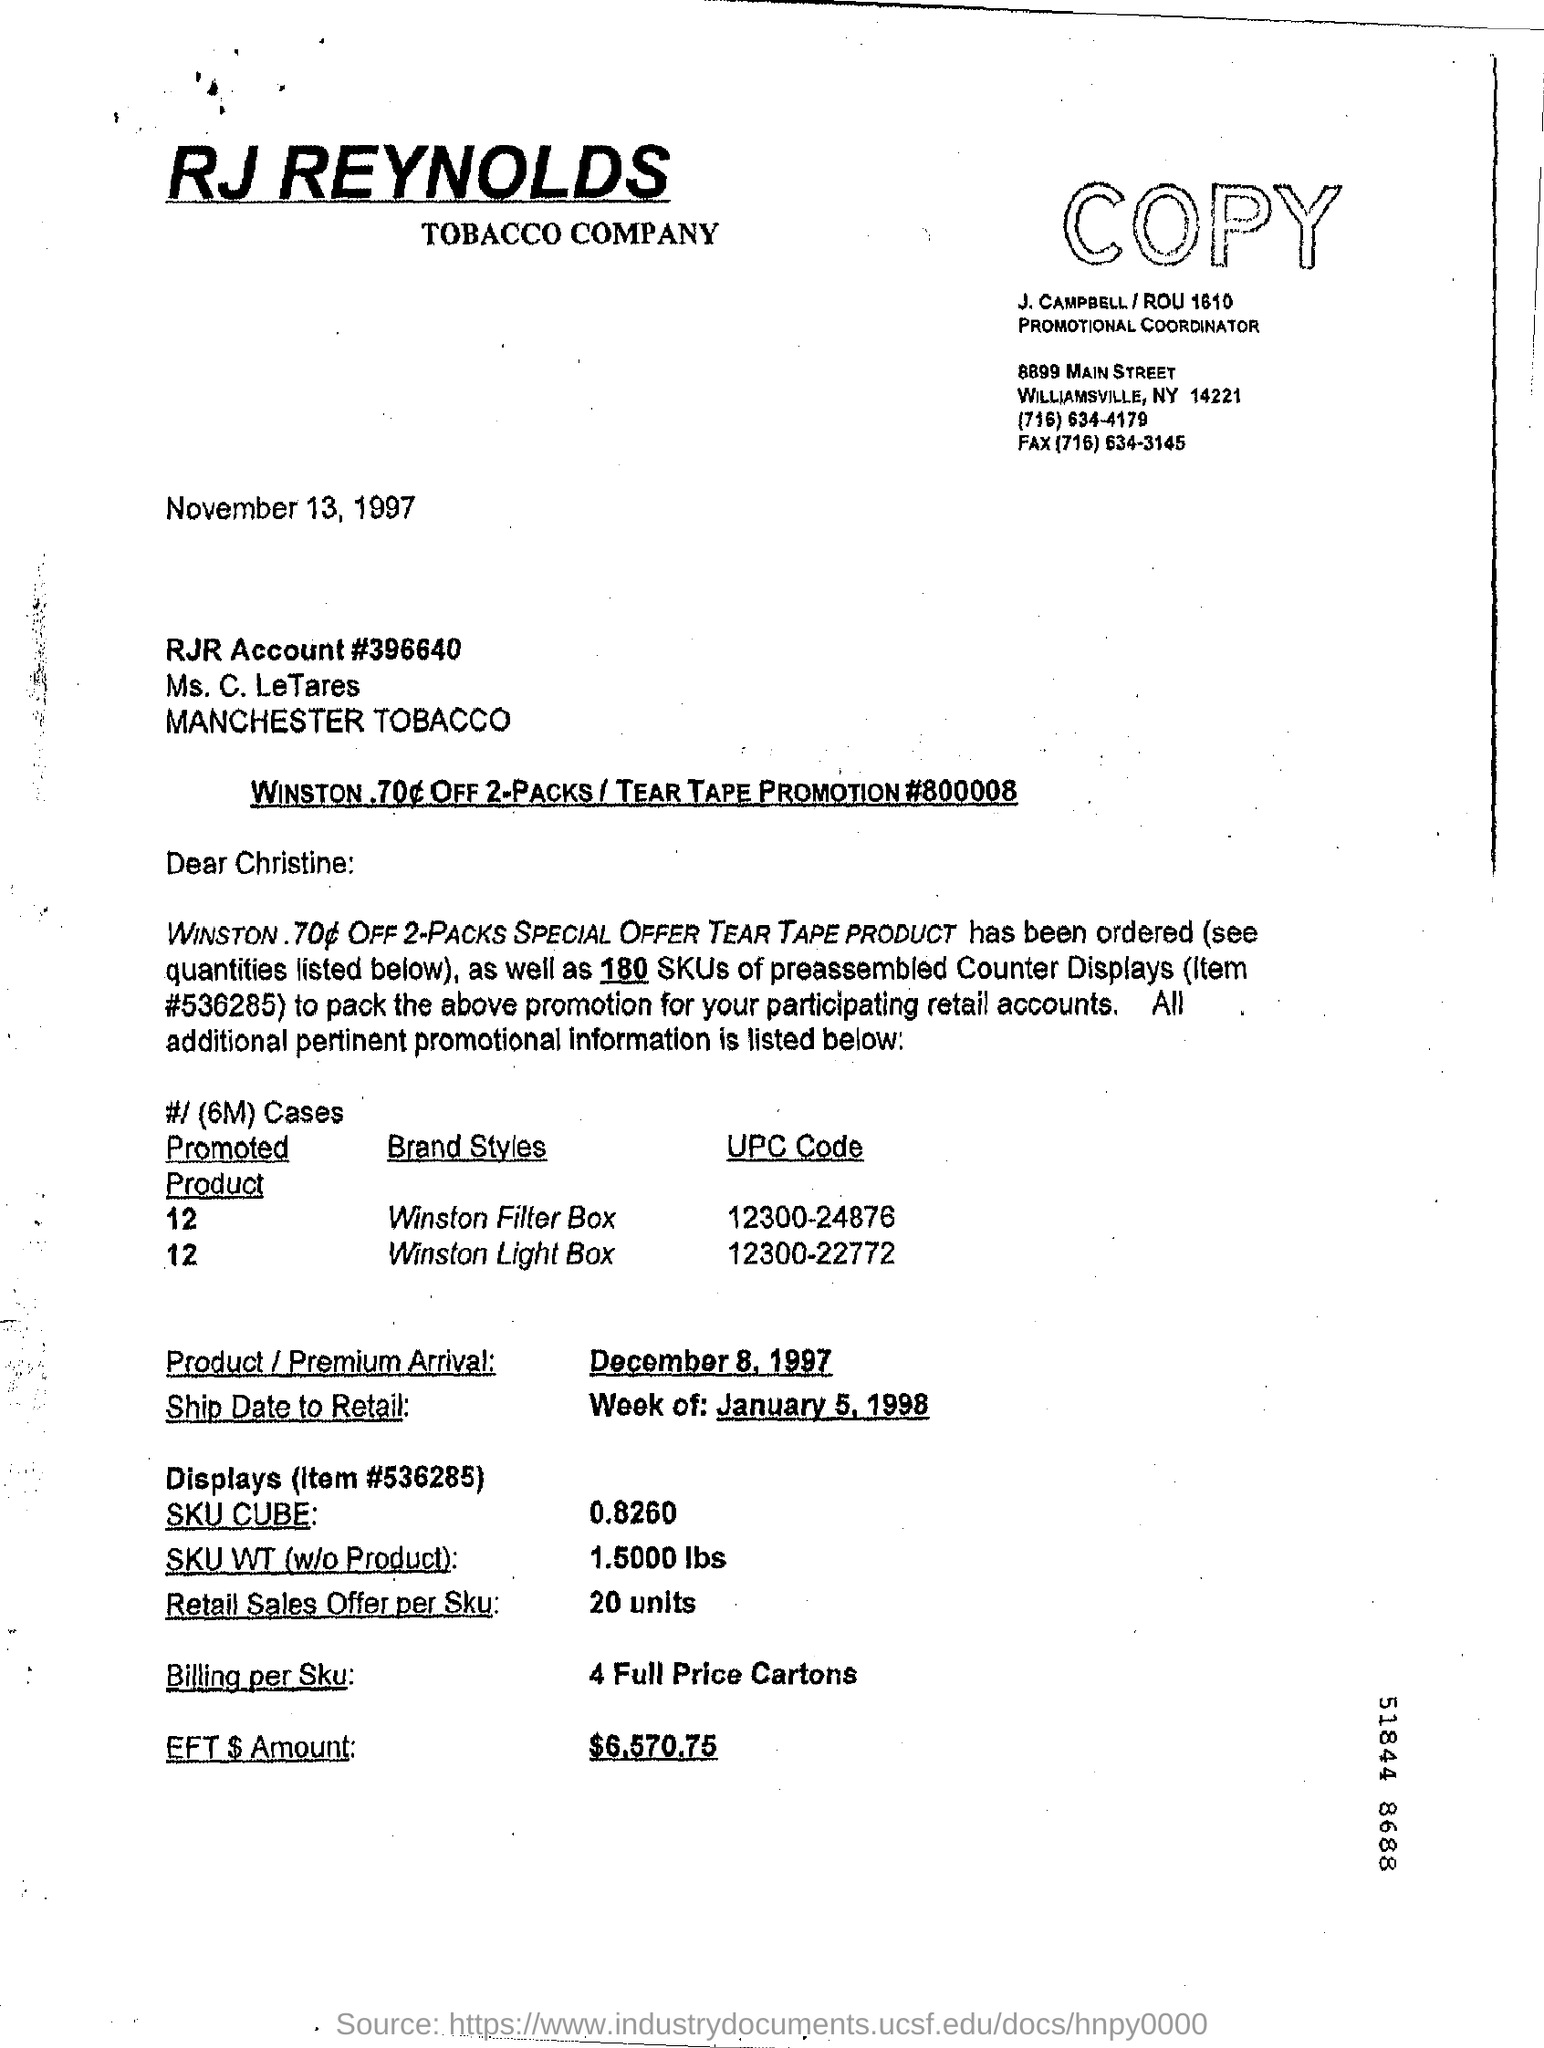Can you tell me what this document is about? This document appears to be a correspondence from RJ Reynolds Tobacco Company, dated November 13, 1997, concerning a promotion for 'Winston .70¢ OFF 2-Packs' tied to a 'Tear Tape Promotion.' It provides detailed information about the product being promoted, the arrival of the product or premium, and specific details related to the shipping, promotion, and billing for retail accounts. 